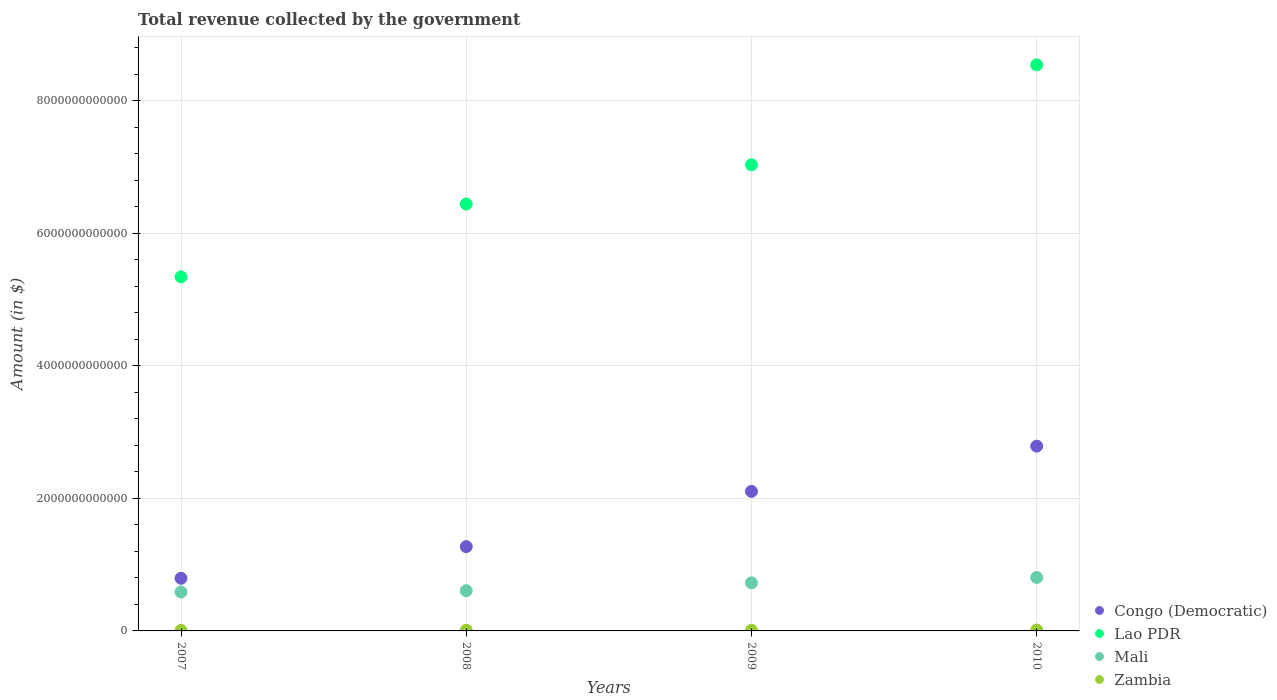What is the total revenue collected by the government in Lao PDR in 2010?
Your answer should be very brief. 8.54e+12. Across all years, what is the maximum total revenue collected by the government in Congo (Democratic)?
Provide a succinct answer. 2.79e+12. Across all years, what is the minimum total revenue collected by the government in Mali?
Offer a very short reply. 5.87e+11. In which year was the total revenue collected by the government in Zambia maximum?
Provide a short and direct response. 2010. What is the total total revenue collected by the government in Lao PDR in the graph?
Ensure brevity in your answer.  2.73e+13. What is the difference between the total revenue collected by the government in Zambia in 2007 and that in 2010?
Offer a very short reply. -5.50e+09. What is the difference between the total revenue collected by the government in Mali in 2009 and the total revenue collected by the government in Zambia in 2008?
Your answer should be compact. 7.15e+11. What is the average total revenue collected by the government in Lao PDR per year?
Make the answer very short. 6.84e+12. In the year 2008, what is the difference between the total revenue collected by the government in Zambia and total revenue collected by the government in Lao PDR?
Keep it short and to the point. -6.43e+12. What is the ratio of the total revenue collected by the government in Lao PDR in 2007 to that in 2009?
Keep it short and to the point. 0.76. Is the total revenue collected by the government in Zambia in 2007 less than that in 2009?
Your response must be concise. Yes. Is the difference between the total revenue collected by the government in Zambia in 2007 and 2010 greater than the difference between the total revenue collected by the government in Lao PDR in 2007 and 2010?
Ensure brevity in your answer.  Yes. What is the difference between the highest and the second highest total revenue collected by the government in Mali?
Your answer should be compact. 8.14e+1. What is the difference between the highest and the lowest total revenue collected by the government in Congo (Democratic)?
Ensure brevity in your answer.  1.99e+12. In how many years, is the total revenue collected by the government in Congo (Democratic) greater than the average total revenue collected by the government in Congo (Democratic) taken over all years?
Provide a succinct answer. 2. Is the sum of the total revenue collected by the government in Zambia in 2008 and 2010 greater than the maximum total revenue collected by the government in Mali across all years?
Your answer should be compact. No. Is it the case that in every year, the sum of the total revenue collected by the government in Congo (Democratic) and total revenue collected by the government in Zambia  is greater than the sum of total revenue collected by the government in Mali and total revenue collected by the government in Lao PDR?
Provide a succinct answer. No. Is it the case that in every year, the sum of the total revenue collected by the government in Lao PDR and total revenue collected by the government in Congo (Democratic)  is greater than the total revenue collected by the government in Mali?
Your response must be concise. Yes. Does the total revenue collected by the government in Lao PDR monotonically increase over the years?
Offer a terse response. Yes. Is the total revenue collected by the government in Congo (Democratic) strictly less than the total revenue collected by the government in Zambia over the years?
Your response must be concise. No. What is the difference between two consecutive major ticks on the Y-axis?
Offer a terse response. 2.00e+12. Does the graph contain grids?
Your response must be concise. Yes. Where does the legend appear in the graph?
Keep it short and to the point. Bottom right. How many legend labels are there?
Keep it short and to the point. 4. How are the legend labels stacked?
Offer a terse response. Vertical. What is the title of the graph?
Your answer should be compact. Total revenue collected by the government. Does "Russian Federation" appear as one of the legend labels in the graph?
Provide a short and direct response. No. What is the label or title of the Y-axis?
Give a very brief answer. Amount (in $). What is the Amount (in $) in Congo (Democratic) in 2007?
Keep it short and to the point. 7.94e+11. What is the Amount (in $) of Lao PDR in 2007?
Make the answer very short. 5.34e+12. What is the Amount (in $) of Mali in 2007?
Keep it short and to the point. 5.87e+11. What is the Amount (in $) in Zambia in 2007?
Provide a short and direct response. 8.04e+09. What is the Amount (in $) of Congo (Democratic) in 2008?
Provide a short and direct response. 1.27e+12. What is the Amount (in $) of Lao PDR in 2008?
Provide a short and direct response. 6.44e+12. What is the Amount (in $) of Mali in 2008?
Your response must be concise. 6.07e+11. What is the Amount (in $) of Zambia in 2008?
Offer a very short reply. 1.01e+1. What is the Amount (in $) in Congo (Democratic) in 2009?
Provide a short and direct response. 2.10e+12. What is the Amount (in $) in Lao PDR in 2009?
Provide a succinct answer. 7.03e+12. What is the Amount (in $) in Mali in 2009?
Make the answer very short. 7.25e+11. What is the Amount (in $) of Zambia in 2009?
Your response must be concise. 1.01e+1. What is the Amount (in $) of Congo (Democratic) in 2010?
Your response must be concise. 2.79e+12. What is the Amount (in $) in Lao PDR in 2010?
Your answer should be very brief. 8.54e+12. What is the Amount (in $) of Mali in 2010?
Provide a succinct answer. 8.06e+11. What is the Amount (in $) of Zambia in 2010?
Offer a terse response. 1.35e+1. Across all years, what is the maximum Amount (in $) of Congo (Democratic)?
Your response must be concise. 2.79e+12. Across all years, what is the maximum Amount (in $) of Lao PDR?
Your answer should be very brief. 8.54e+12. Across all years, what is the maximum Amount (in $) in Mali?
Offer a very short reply. 8.06e+11. Across all years, what is the maximum Amount (in $) of Zambia?
Your answer should be very brief. 1.35e+1. Across all years, what is the minimum Amount (in $) of Congo (Democratic)?
Offer a terse response. 7.94e+11. Across all years, what is the minimum Amount (in $) of Lao PDR?
Give a very brief answer. 5.34e+12. Across all years, what is the minimum Amount (in $) of Mali?
Offer a very short reply. 5.87e+11. Across all years, what is the minimum Amount (in $) of Zambia?
Make the answer very short. 8.04e+09. What is the total Amount (in $) in Congo (Democratic) in the graph?
Your answer should be very brief. 6.96e+12. What is the total Amount (in $) in Lao PDR in the graph?
Provide a succinct answer. 2.73e+13. What is the total Amount (in $) of Mali in the graph?
Keep it short and to the point. 2.73e+12. What is the total Amount (in $) of Zambia in the graph?
Give a very brief answer. 4.17e+1. What is the difference between the Amount (in $) of Congo (Democratic) in 2007 and that in 2008?
Offer a terse response. -4.78e+11. What is the difference between the Amount (in $) of Lao PDR in 2007 and that in 2008?
Your answer should be very brief. -1.10e+12. What is the difference between the Amount (in $) in Mali in 2007 and that in 2008?
Give a very brief answer. -2.04e+1. What is the difference between the Amount (in $) of Zambia in 2007 and that in 2008?
Give a very brief answer. -2.04e+09. What is the difference between the Amount (in $) in Congo (Democratic) in 2007 and that in 2009?
Your response must be concise. -1.31e+12. What is the difference between the Amount (in $) of Lao PDR in 2007 and that in 2009?
Provide a succinct answer. -1.69e+12. What is the difference between the Amount (in $) of Mali in 2007 and that in 2009?
Your answer should be very brief. -1.38e+11. What is the difference between the Amount (in $) in Zambia in 2007 and that in 2009?
Ensure brevity in your answer.  -2.06e+09. What is the difference between the Amount (in $) of Congo (Democratic) in 2007 and that in 2010?
Provide a succinct answer. -1.99e+12. What is the difference between the Amount (in $) in Lao PDR in 2007 and that in 2010?
Ensure brevity in your answer.  -3.20e+12. What is the difference between the Amount (in $) in Mali in 2007 and that in 2010?
Keep it short and to the point. -2.19e+11. What is the difference between the Amount (in $) of Zambia in 2007 and that in 2010?
Your answer should be compact. -5.50e+09. What is the difference between the Amount (in $) of Congo (Democratic) in 2008 and that in 2009?
Give a very brief answer. -8.33e+11. What is the difference between the Amount (in $) of Lao PDR in 2008 and that in 2009?
Offer a very short reply. -5.91e+11. What is the difference between the Amount (in $) of Mali in 2008 and that in 2009?
Offer a very short reply. -1.18e+11. What is the difference between the Amount (in $) in Zambia in 2008 and that in 2009?
Your answer should be very brief. -2.46e+07. What is the difference between the Amount (in $) in Congo (Democratic) in 2008 and that in 2010?
Ensure brevity in your answer.  -1.52e+12. What is the difference between the Amount (in $) of Lao PDR in 2008 and that in 2010?
Offer a terse response. -2.10e+12. What is the difference between the Amount (in $) in Mali in 2008 and that in 2010?
Give a very brief answer. -1.99e+11. What is the difference between the Amount (in $) in Zambia in 2008 and that in 2010?
Provide a succinct answer. -3.46e+09. What is the difference between the Amount (in $) of Congo (Democratic) in 2009 and that in 2010?
Ensure brevity in your answer.  -6.82e+11. What is the difference between the Amount (in $) of Lao PDR in 2009 and that in 2010?
Provide a succinct answer. -1.51e+12. What is the difference between the Amount (in $) of Mali in 2009 and that in 2010?
Give a very brief answer. -8.14e+1. What is the difference between the Amount (in $) of Zambia in 2009 and that in 2010?
Your answer should be compact. -3.43e+09. What is the difference between the Amount (in $) in Congo (Democratic) in 2007 and the Amount (in $) in Lao PDR in 2008?
Offer a terse response. -5.65e+12. What is the difference between the Amount (in $) in Congo (Democratic) in 2007 and the Amount (in $) in Mali in 2008?
Give a very brief answer. 1.86e+11. What is the difference between the Amount (in $) in Congo (Democratic) in 2007 and the Amount (in $) in Zambia in 2008?
Make the answer very short. 7.84e+11. What is the difference between the Amount (in $) of Lao PDR in 2007 and the Amount (in $) of Mali in 2008?
Ensure brevity in your answer.  4.73e+12. What is the difference between the Amount (in $) of Lao PDR in 2007 and the Amount (in $) of Zambia in 2008?
Your answer should be very brief. 5.33e+12. What is the difference between the Amount (in $) of Mali in 2007 and the Amount (in $) of Zambia in 2008?
Make the answer very short. 5.77e+11. What is the difference between the Amount (in $) in Congo (Democratic) in 2007 and the Amount (in $) in Lao PDR in 2009?
Provide a short and direct response. -6.24e+12. What is the difference between the Amount (in $) in Congo (Democratic) in 2007 and the Amount (in $) in Mali in 2009?
Provide a short and direct response. 6.88e+1. What is the difference between the Amount (in $) of Congo (Democratic) in 2007 and the Amount (in $) of Zambia in 2009?
Your answer should be compact. 7.84e+11. What is the difference between the Amount (in $) of Lao PDR in 2007 and the Amount (in $) of Mali in 2009?
Provide a short and direct response. 4.62e+12. What is the difference between the Amount (in $) in Lao PDR in 2007 and the Amount (in $) in Zambia in 2009?
Offer a very short reply. 5.33e+12. What is the difference between the Amount (in $) of Mali in 2007 and the Amount (in $) of Zambia in 2009?
Provide a short and direct response. 5.77e+11. What is the difference between the Amount (in $) of Congo (Democratic) in 2007 and the Amount (in $) of Lao PDR in 2010?
Your answer should be compact. -7.74e+12. What is the difference between the Amount (in $) of Congo (Democratic) in 2007 and the Amount (in $) of Mali in 2010?
Your response must be concise. -1.26e+1. What is the difference between the Amount (in $) in Congo (Democratic) in 2007 and the Amount (in $) in Zambia in 2010?
Provide a short and direct response. 7.80e+11. What is the difference between the Amount (in $) in Lao PDR in 2007 and the Amount (in $) in Mali in 2010?
Make the answer very short. 4.53e+12. What is the difference between the Amount (in $) in Lao PDR in 2007 and the Amount (in $) in Zambia in 2010?
Offer a terse response. 5.33e+12. What is the difference between the Amount (in $) in Mali in 2007 and the Amount (in $) in Zambia in 2010?
Ensure brevity in your answer.  5.73e+11. What is the difference between the Amount (in $) in Congo (Democratic) in 2008 and the Amount (in $) in Lao PDR in 2009?
Your answer should be very brief. -5.76e+12. What is the difference between the Amount (in $) in Congo (Democratic) in 2008 and the Amount (in $) in Mali in 2009?
Your response must be concise. 5.47e+11. What is the difference between the Amount (in $) in Congo (Democratic) in 2008 and the Amount (in $) in Zambia in 2009?
Offer a terse response. 1.26e+12. What is the difference between the Amount (in $) in Lao PDR in 2008 and the Amount (in $) in Mali in 2009?
Keep it short and to the point. 5.71e+12. What is the difference between the Amount (in $) in Lao PDR in 2008 and the Amount (in $) in Zambia in 2009?
Your answer should be compact. 6.43e+12. What is the difference between the Amount (in $) in Mali in 2008 and the Amount (in $) in Zambia in 2009?
Make the answer very short. 5.97e+11. What is the difference between the Amount (in $) of Congo (Democratic) in 2008 and the Amount (in $) of Lao PDR in 2010?
Offer a terse response. -7.27e+12. What is the difference between the Amount (in $) of Congo (Democratic) in 2008 and the Amount (in $) of Mali in 2010?
Give a very brief answer. 4.65e+11. What is the difference between the Amount (in $) in Congo (Democratic) in 2008 and the Amount (in $) in Zambia in 2010?
Offer a very short reply. 1.26e+12. What is the difference between the Amount (in $) in Lao PDR in 2008 and the Amount (in $) in Mali in 2010?
Your response must be concise. 5.63e+12. What is the difference between the Amount (in $) in Lao PDR in 2008 and the Amount (in $) in Zambia in 2010?
Ensure brevity in your answer.  6.43e+12. What is the difference between the Amount (in $) in Mali in 2008 and the Amount (in $) in Zambia in 2010?
Ensure brevity in your answer.  5.94e+11. What is the difference between the Amount (in $) in Congo (Democratic) in 2009 and the Amount (in $) in Lao PDR in 2010?
Give a very brief answer. -6.43e+12. What is the difference between the Amount (in $) in Congo (Democratic) in 2009 and the Amount (in $) in Mali in 2010?
Give a very brief answer. 1.30e+12. What is the difference between the Amount (in $) of Congo (Democratic) in 2009 and the Amount (in $) of Zambia in 2010?
Your response must be concise. 2.09e+12. What is the difference between the Amount (in $) of Lao PDR in 2009 and the Amount (in $) of Mali in 2010?
Your answer should be compact. 6.22e+12. What is the difference between the Amount (in $) in Lao PDR in 2009 and the Amount (in $) in Zambia in 2010?
Keep it short and to the point. 7.02e+12. What is the difference between the Amount (in $) of Mali in 2009 and the Amount (in $) of Zambia in 2010?
Keep it short and to the point. 7.11e+11. What is the average Amount (in $) in Congo (Democratic) per year?
Give a very brief answer. 1.74e+12. What is the average Amount (in $) in Lao PDR per year?
Give a very brief answer. 6.84e+12. What is the average Amount (in $) in Mali per year?
Provide a succinct answer. 6.81e+11. What is the average Amount (in $) of Zambia per year?
Offer a terse response. 1.04e+1. In the year 2007, what is the difference between the Amount (in $) in Congo (Democratic) and Amount (in $) in Lao PDR?
Your response must be concise. -4.55e+12. In the year 2007, what is the difference between the Amount (in $) in Congo (Democratic) and Amount (in $) in Mali?
Offer a terse response. 2.07e+11. In the year 2007, what is the difference between the Amount (in $) in Congo (Democratic) and Amount (in $) in Zambia?
Offer a very short reply. 7.86e+11. In the year 2007, what is the difference between the Amount (in $) in Lao PDR and Amount (in $) in Mali?
Give a very brief answer. 4.75e+12. In the year 2007, what is the difference between the Amount (in $) of Lao PDR and Amount (in $) of Zambia?
Your answer should be compact. 5.33e+12. In the year 2007, what is the difference between the Amount (in $) in Mali and Amount (in $) in Zambia?
Ensure brevity in your answer.  5.79e+11. In the year 2008, what is the difference between the Amount (in $) in Congo (Democratic) and Amount (in $) in Lao PDR?
Provide a short and direct response. -5.17e+12. In the year 2008, what is the difference between the Amount (in $) of Congo (Democratic) and Amount (in $) of Mali?
Offer a very short reply. 6.64e+11. In the year 2008, what is the difference between the Amount (in $) in Congo (Democratic) and Amount (in $) in Zambia?
Your answer should be compact. 1.26e+12. In the year 2008, what is the difference between the Amount (in $) in Lao PDR and Amount (in $) in Mali?
Give a very brief answer. 5.83e+12. In the year 2008, what is the difference between the Amount (in $) of Lao PDR and Amount (in $) of Zambia?
Offer a very short reply. 6.43e+12. In the year 2008, what is the difference between the Amount (in $) in Mali and Amount (in $) in Zambia?
Offer a very short reply. 5.97e+11. In the year 2009, what is the difference between the Amount (in $) in Congo (Democratic) and Amount (in $) in Lao PDR?
Make the answer very short. -4.93e+12. In the year 2009, what is the difference between the Amount (in $) in Congo (Democratic) and Amount (in $) in Mali?
Provide a short and direct response. 1.38e+12. In the year 2009, what is the difference between the Amount (in $) in Congo (Democratic) and Amount (in $) in Zambia?
Keep it short and to the point. 2.09e+12. In the year 2009, what is the difference between the Amount (in $) in Lao PDR and Amount (in $) in Mali?
Provide a short and direct response. 6.31e+12. In the year 2009, what is the difference between the Amount (in $) of Lao PDR and Amount (in $) of Zambia?
Give a very brief answer. 7.02e+12. In the year 2009, what is the difference between the Amount (in $) in Mali and Amount (in $) in Zambia?
Provide a succinct answer. 7.15e+11. In the year 2010, what is the difference between the Amount (in $) in Congo (Democratic) and Amount (in $) in Lao PDR?
Offer a terse response. -5.75e+12. In the year 2010, what is the difference between the Amount (in $) in Congo (Democratic) and Amount (in $) in Mali?
Offer a terse response. 1.98e+12. In the year 2010, what is the difference between the Amount (in $) in Congo (Democratic) and Amount (in $) in Zambia?
Provide a short and direct response. 2.77e+12. In the year 2010, what is the difference between the Amount (in $) in Lao PDR and Amount (in $) in Mali?
Give a very brief answer. 7.73e+12. In the year 2010, what is the difference between the Amount (in $) of Lao PDR and Amount (in $) of Zambia?
Offer a very short reply. 8.52e+12. In the year 2010, what is the difference between the Amount (in $) of Mali and Amount (in $) of Zambia?
Your answer should be compact. 7.93e+11. What is the ratio of the Amount (in $) of Congo (Democratic) in 2007 to that in 2008?
Your answer should be very brief. 0.62. What is the ratio of the Amount (in $) in Lao PDR in 2007 to that in 2008?
Give a very brief answer. 0.83. What is the ratio of the Amount (in $) of Mali in 2007 to that in 2008?
Keep it short and to the point. 0.97. What is the ratio of the Amount (in $) in Zambia in 2007 to that in 2008?
Provide a short and direct response. 0.8. What is the ratio of the Amount (in $) in Congo (Democratic) in 2007 to that in 2009?
Ensure brevity in your answer.  0.38. What is the ratio of the Amount (in $) of Lao PDR in 2007 to that in 2009?
Your answer should be compact. 0.76. What is the ratio of the Amount (in $) in Mali in 2007 to that in 2009?
Your answer should be compact. 0.81. What is the ratio of the Amount (in $) in Zambia in 2007 to that in 2009?
Give a very brief answer. 0.8. What is the ratio of the Amount (in $) in Congo (Democratic) in 2007 to that in 2010?
Offer a terse response. 0.28. What is the ratio of the Amount (in $) in Lao PDR in 2007 to that in 2010?
Offer a terse response. 0.63. What is the ratio of the Amount (in $) of Mali in 2007 to that in 2010?
Offer a very short reply. 0.73. What is the ratio of the Amount (in $) of Zambia in 2007 to that in 2010?
Offer a very short reply. 0.59. What is the ratio of the Amount (in $) in Congo (Democratic) in 2008 to that in 2009?
Offer a very short reply. 0.6. What is the ratio of the Amount (in $) of Lao PDR in 2008 to that in 2009?
Ensure brevity in your answer.  0.92. What is the ratio of the Amount (in $) in Mali in 2008 to that in 2009?
Keep it short and to the point. 0.84. What is the ratio of the Amount (in $) in Congo (Democratic) in 2008 to that in 2010?
Your answer should be compact. 0.46. What is the ratio of the Amount (in $) of Lao PDR in 2008 to that in 2010?
Offer a terse response. 0.75. What is the ratio of the Amount (in $) in Mali in 2008 to that in 2010?
Offer a terse response. 0.75. What is the ratio of the Amount (in $) of Zambia in 2008 to that in 2010?
Provide a succinct answer. 0.74. What is the ratio of the Amount (in $) of Congo (Democratic) in 2009 to that in 2010?
Your answer should be very brief. 0.76. What is the ratio of the Amount (in $) in Lao PDR in 2009 to that in 2010?
Provide a short and direct response. 0.82. What is the ratio of the Amount (in $) in Mali in 2009 to that in 2010?
Ensure brevity in your answer.  0.9. What is the ratio of the Amount (in $) of Zambia in 2009 to that in 2010?
Your answer should be very brief. 0.75. What is the difference between the highest and the second highest Amount (in $) in Congo (Democratic)?
Ensure brevity in your answer.  6.82e+11. What is the difference between the highest and the second highest Amount (in $) in Lao PDR?
Your answer should be very brief. 1.51e+12. What is the difference between the highest and the second highest Amount (in $) of Mali?
Keep it short and to the point. 8.14e+1. What is the difference between the highest and the second highest Amount (in $) of Zambia?
Provide a succinct answer. 3.43e+09. What is the difference between the highest and the lowest Amount (in $) in Congo (Democratic)?
Offer a very short reply. 1.99e+12. What is the difference between the highest and the lowest Amount (in $) in Lao PDR?
Provide a short and direct response. 3.20e+12. What is the difference between the highest and the lowest Amount (in $) of Mali?
Offer a very short reply. 2.19e+11. What is the difference between the highest and the lowest Amount (in $) in Zambia?
Your answer should be very brief. 5.50e+09. 